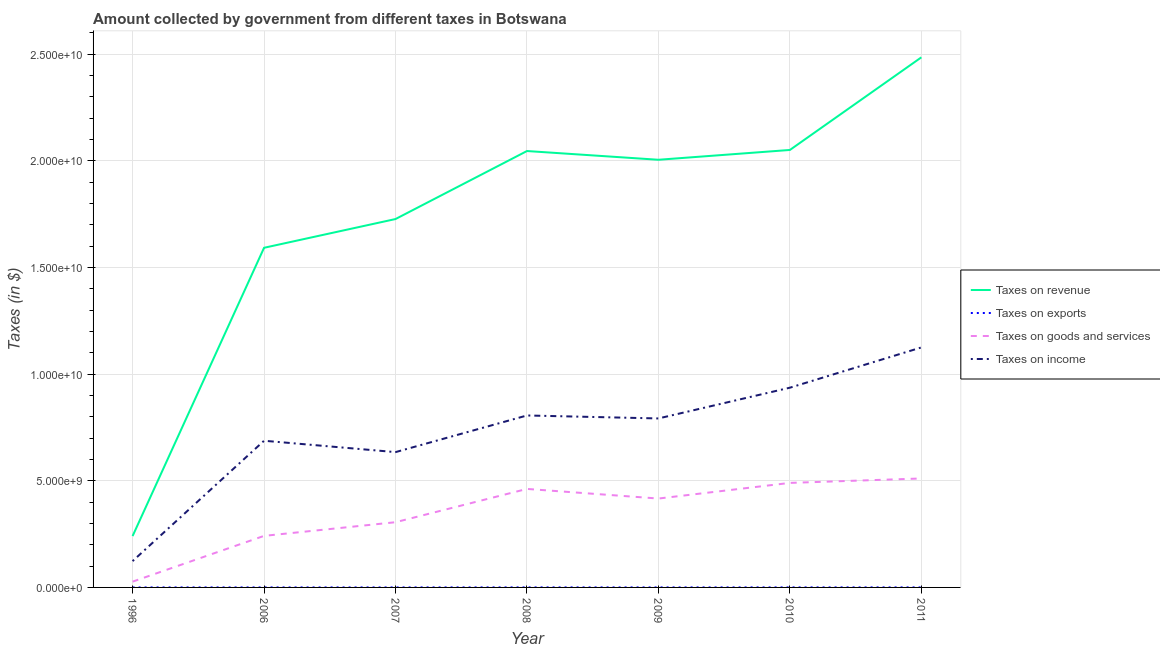What is the amount collected as tax on goods in 2009?
Your response must be concise. 4.17e+09. Across all years, what is the maximum amount collected as tax on exports?
Ensure brevity in your answer.  1.69e+06. Across all years, what is the minimum amount collected as tax on revenue?
Make the answer very short. 2.41e+09. In which year was the amount collected as tax on income minimum?
Provide a short and direct response. 1996. What is the total amount collected as tax on income in the graph?
Ensure brevity in your answer.  5.10e+1. What is the difference between the amount collected as tax on exports in 1996 and that in 2010?
Make the answer very short. -1.39e+06. What is the difference between the amount collected as tax on income in 2006 and the amount collected as tax on exports in 2008?
Keep it short and to the point. 6.87e+09. What is the average amount collected as tax on goods per year?
Keep it short and to the point. 3.50e+09. In the year 2011, what is the difference between the amount collected as tax on goods and amount collected as tax on revenue?
Offer a terse response. -1.97e+1. In how many years, is the amount collected as tax on goods greater than 11000000000 $?
Offer a terse response. 0. What is the ratio of the amount collected as tax on income in 2009 to that in 2010?
Offer a terse response. 0.85. Is the amount collected as tax on goods in 2009 less than that in 2010?
Keep it short and to the point. Yes. What is the difference between the highest and the second highest amount collected as tax on goods?
Make the answer very short. 2.08e+08. What is the difference between the highest and the lowest amount collected as tax on goods?
Your response must be concise. 4.84e+09. In how many years, is the amount collected as tax on goods greater than the average amount collected as tax on goods taken over all years?
Provide a succinct answer. 4. Is the sum of the amount collected as tax on exports in 2009 and 2011 greater than the maximum amount collected as tax on revenue across all years?
Your answer should be very brief. No. Does the amount collected as tax on goods monotonically increase over the years?
Provide a succinct answer. No. Is the amount collected as tax on goods strictly greater than the amount collected as tax on revenue over the years?
Keep it short and to the point. No. Is the amount collected as tax on exports strictly less than the amount collected as tax on income over the years?
Provide a short and direct response. Yes. How many lines are there?
Give a very brief answer. 4. How many years are there in the graph?
Keep it short and to the point. 7. Does the graph contain any zero values?
Your answer should be very brief. No. Does the graph contain grids?
Make the answer very short. Yes. How many legend labels are there?
Your answer should be compact. 4. What is the title of the graph?
Provide a short and direct response. Amount collected by government from different taxes in Botswana. Does "Taxes on income" appear as one of the legend labels in the graph?
Ensure brevity in your answer.  Yes. What is the label or title of the X-axis?
Ensure brevity in your answer.  Year. What is the label or title of the Y-axis?
Ensure brevity in your answer.  Taxes (in $). What is the Taxes (in $) in Taxes on revenue in 1996?
Your response must be concise. 2.41e+09. What is the Taxes (in $) in Taxes on exports in 1996?
Keep it short and to the point. 3.00e+05. What is the Taxes (in $) in Taxes on goods and services in 1996?
Offer a very short reply. 2.71e+08. What is the Taxes (in $) of Taxes on income in 1996?
Keep it short and to the point. 1.23e+09. What is the Taxes (in $) in Taxes on revenue in 2006?
Keep it short and to the point. 1.59e+1. What is the Taxes (in $) in Taxes on exports in 2006?
Your response must be concise. 3.60e+05. What is the Taxes (in $) of Taxes on goods and services in 2006?
Provide a short and direct response. 2.42e+09. What is the Taxes (in $) in Taxes on income in 2006?
Offer a terse response. 6.88e+09. What is the Taxes (in $) of Taxes on revenue in 2007?
Your answer should be compact. 1.73e+1. What is the Taxes (in $) in Taxes on goods and services in 2007?
Provide a short and direct response. 3.06e+09. What is the Taxes (in $) in Taxes on income in 2007?
Provide a short and direct response. 6.34e+09. What is the Taxes (in $) of Taxes on revenue in 2008?
Your answer should be compact. 2.05e+1. What is the Taxes (in $) in Taxes on exports in 2008?
Give a very brief answer. 1.65e+06. What is the Taxes (in $) of Taxes on goods and services in 2008?
Offer a terse response. 4.62e+09. What is the Taxes (in $) of Taxes on income in 2008?
Keep it short and to the point. 8.06e+09. What is the Taxes (in $) in Taxes on revenue in 2009?
Make the answer very short. 2.00e+1. What is the Taxes (in $) of Taxes on exports in 2009?
Make the answer very short. 7.10e+05. What is the Taxes (in $) of Taxes on goods and services in 2009?
Offer a very short reply. 4.17e+09. What is the Taxes (in $) in Taxes on income in 2009?
Your answer should be very brief. 7.92e+09. What is the Taxes (in $) of Taxes on revenue in 2010?
Your response must be concise. 2.05e+1. What is the Taxes (in $) in Taxes on exports in 2010?
Make the answer very short. 1.69e+06. What is the Taxes (in $) of Taxes on goods and services in 2010?
Your response must be concise. 4.90e+09. What is the Taxes (in $) in Taxes on income in 2010?
Your response must be concise. 9.36e+09. What is the Taxes (in $) in Taxes on revenue in 2011?
Your response must be concise. 2.48e+1. What is the Taxes (in $) in Taxes on exports in 2011?
Your answer should be compact. 1.36e+06. What is the Taxes (in $) in Taxes on goods and services in 2011?
Ensure brevity in your answer.  5.11e+09. What is the Taxes (in $) of Taxes on income in 2011?
Your response must be concise. 1.12e+1. Across all years, what is the maximum Taxes (in $) of Taxes on revenue?
Your answer should be very brief. 2.48e+1. Across all years, what is the maximum Taxes (in $) in Taxes on exports?
Your answer should be compact. 1.69e+06. Across all years, what is the maximum Taxes (in $) of Taxes on goods and services?
Make the answer very short. 5.11e+09. Across all years, what is the maximum Taxes (in $) of Taxes on income?
Ensure brevity in your answer.  1.12e+1. Across all years, what is the minimum Taxes (in $) in Taxes on revenue?
Offer a terse response. 2.41e+09. Across all years, what is the minimum Taxes (in $) of Taxes on exports?
Provide a short and direct response. 3.00e+05. Across all years, what is the minimum Taxes (in $) of Taxes on goods and services?
Provide a short and direct response. 2.71e+08. Across all years, what is the minimum Taxes (in $) in Taxes on income?
Your response must be concise. 1.23e+09. What is the total Taxes (in $) in Taxes on revenue in the graph?
Ensure brevity in your answer.  1.21e+11. What is the total Taxes (in $) of Taxes on exports in the graph?
Your answer should be very brief. 6.51e+06. What is the total Taxes (in $) in Taxes on goods and services in the graph?
Keep it short and to the point. 2.45e+1. What is the total Taxes (in $) in Taxes on income in the graph?
Ensure brevity in your answer.  5.10e+1. What is the difference between the Taxes (in $) in Taxes on revenue in 1996 and that in 2006?
Give a very brief answer. -1.35e+1. What is the difference between the Taxes (in $) in Taxes on exports in 1996 and that in 2006?
Keep it short and to the point. -6.00e+04. What is the difference between the Taxes (in $) in Taxes on goods and services in 1996 and that in 2006?
Ensure brevity in your answer.  -2.14e+09. What is the difference between the Taxes (in $) in Taxes on income in 1996 and that in 2006?
Offer a very short reply. -5.64e+09. What is the difference between the Taxes (in $) in Taxes on revenue in 1996 and that in 2007?
Make the answer very short. -1.49e+1. What is the difference between the Taxes (in $) of Taxes on goods and services in 1996 and that in 2007?
Ensure brevity in your answer.  -2.79e+09. What is the difference between the Taxes (in $) in Taxes on income in 1996 and that in 2007?
Give a very brief answer. -5.11e+09. What is the difference between the Taxes (in $) of Taxes on revenue in 1996 and that in 2008?
Provide a short and direct response. -1.80e+1. What is the difference between the Taxes (in $) of Taxes on exports in 1996 and that in 2008?
Keep it short and to the point. -1.35e+06. What is the difference between the Taxes (in $) in Taxes on goods and services in 1996 and that in 2008?
Keep it short and to the point. -4.35e+09. What is the difference between the Taxes (in $) of Taxes on income in 1996 and that in 2008?
Your answer should be compact. -6.83e+09. What is the difference between the Taxes (in $) in Taxes on revenue in 1996 and that in 2009?
Make the answer very short. -1.76e+1. What is the difference between the Taxes (in $) of Taxes on exports in 1996 and that in 2009?
Your answer should be very brief. -4.10e+05. What is the difference between the Taxes (in $) in Taxes on goods and services in 1996 and that in 2009?
Your answer should be compact. -3.89e+09. What is the difference between the Taxes (in $) of Taxes on income in 1996 and that in 2009?
Your response must be concise. -6.69e+09. What is the difference between the Taxes (in $) in Taxes on revenue in 1996 and that in 2010?
Your response must be concise. -1.81e+1. What is the difference between the Taxes (in $) of Taxes on exports in 1996 and that in 2010?
Give a very brief answer. -1.39e+06. What is the difference between the Taxes (in $) of Taxes on goods and services in 1996 and that in 2010?
Your answer should be compact. -4.63e+09. What is the difference between the Taxes (in $) of Taxes on income in 1996 and that in 2010?
Keep it short and to the point. -8.13e+09. What is the difference between the Taxes (in $) in Taxes on revenue in 1996 and that in 2011?
Provide a short and direct response. -2.24e+1. What is the difference between the Taxes (in $) of Taxes on exports in 1996 and that in 2011?
Provide a succinct answer. -1.06e+06. What is the difference between the Taxes (in $) of Taxes on goods and services in 1996 and that in 2011?
Provide a short and direct response. -4.84e+09. What is the difference between the Taxes (in $) in Taxes on income in 1996 and that in 2011?
Provide a succinct answer. -1.00e+1. What is the difference between the Taxes (in $) in Taxes on revenue in 2006 and that in 2007?
Your answer should be very brief. -1.35e+09. What is the difference between the Taxes (in $) of Taxes on exports in 2006 and that in 2007?
Offer a terse response. -8.00e+04. What is the difference between the Taxes (in $) of Taxes on goods and services in 2006 and that in 2007?
Offer a very short reply. -6.41e+08. What is the difference between the Taxes (in $) in Taxes on income in 2006 and that in 2007?
Offer a very short reply. 5.33e+08. What is the difference between the Taxes (in $) in Taxes on revenue in 2006 and that in 2008?
Provide a succinct answer. -4.54e+09. What is the difference between the Taxes (in $) of Taxes on exports in 2006 and that in 2008?
Make the answer very short. -1.29e+06. What is the difference between the Taxes (in $) in Taxes on goods and services in 2006 and that in 2008?
Provide a succinct answer. -2.20e+09. What is the difference between the Taxes (in $) of Taxes on income in 2006 and that in 2008?
Ensure brevity in your answer.  -1.18e+09. What is the difference between the Taxes (in $) of Taxes on revenue in 2006 and that in 2009?
Provide a short and direct response. -4.13e+09. What is the difference between the Taxes (in $) in Taxes on exports in 2006 and that in 2009?
Give a very brief answer. -3.50e+05. What is the difference between the Taxes (in $) in Taxes on goods and services in 2006 and that in 2009?
Offer a terse response. -1.75e+09. What is the difference between the Taxes (in $) in Taxes on income in 2006 and that in 2009?
Your response must be concise. -1.05e+09. What is the difference between the Taxes (in $) in Taxes on revenue in 2006 and that in 2010?
Provide a succinct answer. -4.59e+09. What is the difference between the Taxes (in $) of Taxes on exports in 2006 and that in 2010?
Offer a terse response. -1.33e+06. What is the difference between the Taxes (in $) of Taxes on goods and services in 2006 and that in 2010?
Make the answer very short. -2.48e+09. What is the difference between the Taxes (in $) of Taxes on income in 2006 and that in 2010?
Make the answer very short. -2.49e+09. What is the difference between the Taxes (in $) in Taxes on revenue in 2006 and that in 2011?
Your answer should be very brief. -8.93e+09. What is the difference between the Taxes (in $) of Taxes on goods and services in 2006 and that in 2011?
Offer a very short reply. -2.69e+09. What is the difference between the Taxes (in $) in Taxes on income in 2006 and that in 2011?
Offer a terse response. -4.37e+09. What is the difference between the Taxes (in $) of Taxes on revenue in 2007 and that in 2008?
Keep it short and to the point. -3.19e+09. What is the difference between the Taxes (in $) of Taxes on exports in 2007 and that in 2008?
Offer a terse response. -1.21e+06. What is the difference between the Taxes (in $) in Taxes on goods and services in 2007 and that in 2008?
Give a very brief answer. -1.56e+09. What is the difference between the Taxes (in $) of Taxes on income in 2007 and that in 2008?
Your answer should be very brief. -1.72e+09. What is the difference between the Taxes (in $) in Taxes on revenue in 2007 and that in 2009?
Offer a very short reply. -2.78e+09. What is the difference between the Taxes (in $) in Taxes on goods and services in 2007 and that in 2009?
Ensure brevity in your answer.  -1.11e+09. What is the difference between the Taxes (in $) of Taxes on income in 2007 and that in 2009?
Make the answer very short. -1.58e+09. What is the difference between the Taxes (in $) of Taxes on revenue in 2007 and that in 2010?
Offer a terse response. -3.24e+09. What is the difference between the Taxes (in $) in Taxes on exports in 2007 and that in 2010?
Provide a short and direct response. -1.25e+06. What is the difference between the Taxes (in $) of Taxes on goods and services in 2007 and that in 2010?
Your answer should be very brief. -1.84e+09. What is the difference between the Taxes (in $) of Taxes on income in 2007 and that in 2010?
Provide a short and direct response. -3.02e+09. What is the difference between the Taxes (in $) in Taxes on revenue in 2007 and that in 2011?
Make the answer very short. -7.58e+09. What is the difference between the Taxes (in $) in Taxes on exports in 2007 and that in 2011?
Ensure brevity in your answer.  -9.20e+05. What is the difference between the Taxes (in $) of Taxes on goods and services in 2007 and that in 2011?
Offer a terse response. -2.05e+09. What is the difference between the Taxes (in $) of Taxes on income in 2007 and that in 2011?
Ensure brevity in your answer.  -4.91e+09. What is the difference between the Taxes (in $) in Taxes on revenue in 2008 and that in 2009?
Provide a succinct answer. 4.09e+08. What is the difference between the Taxes (in $) of Taxes on exports in 2008 and that in 2009?
Keep it short and to the point. 9.40e+05. What is the difference between the Taxes (in $) in Taxes on goods and services in 2008 and that in 2009?
Your answer should be very brief. 4.51e+08. What is the difference between the Taxes (in $) of Taxes on income in 2008 and that in 2009?
Ensure brevity in your answer.  1.40e+08. What is the difference between the Taxes (in $) of Taxes on revenue in 2008 and that in 2010?
Provide a short and direct response. -5.03e+07. What is the difference between the Taxes (in $) of Taxes on exports in 2008 and that in 2010?
Give a very brief answer. -4.00e+04. What is the difference between the Taxes (in $) of Taxes on goods and services in 2008 and that in 2010?
Give a very brief answer. -2.82e+08. What is the difference between the Taxes (in $) in Taxes on income in 2008 and that in 2010?
Make the answer very short. -1.30e+09. What is the difference between the Taxes (in $) of Taxes on revenue in 2008 and that in 2011?
Your response must be concise. -4.39e+09. What is the difference between the Taxes (in $) in Taxes on exports in 2008 and that in 2011?
Make the answer very short. 2.90e+05. What is the difference between the Taxes (in $) in Taxes on goods and services in 2008 and that in 2011?
Keep it short and to the point. -4.90e+08. What is the difference between the Taxes (in $) of Taxes on income in 2008 and that in 2011?
Provide a succinct answer. -3.19e+09. What is the difference between the Taxes (in $) in Taxes on revenue in 2009 and that in 2010?
Provide a short and direct response. -4.60e+08. What is the difference between the Taxes (in $) in Taxes on exports in 2009 and that in 2010?
Your answer should be very brief. -9.80e+05. What is the difference between the Taxes (in $) of Taxes on goods and services in 2009 and that in 2010?
Keep it short and to the point. -7.34e+08. What is the difference between the Taxes (in $) in Taxes on income in 2009 and that in 2010?
Provide a succinct answer. -1.44e+09. What is the difference between the Taxes (in $) in Taxes on revenue in 2009 and that in 2011?
Keep it short and to the point. -4.80e+09. What is the difference between the Taxes (in $) in Taxes on exports in 2009 and that in 2011?
Give a very brief answer. -6.50e+05. What is the difference between the Taxes (in $) of Taxes on goods and services in 2009 and that in 2011?
Offer a terse response. -9.41e+08. What is the difference between the Taxes (in $) in Taxes on income in 2009 and that in 2011?
Provide a succinct answer. -3.33e+09. What is the difference between the Taxes (in $) in Taxes on revenue in 2010 and that in 2011?
Your answer should be compact. -4.34e+09. What is the difference between the Taxes (in $) of Taxes on exports in 2010 and that in 2011?
Ensure brevity in your answer.  3.30e+05. What is the difference between the Taxes (in $) of Taxes on goods and services in 2010 and that in 2011?
Give a very brief answer. -2.08e+08. What is the difference between the Taxes (in $) of Taxes on income in 2010 and that in 2011?
Provide a succinct answer. -1.89e+09. What is the difference between the Taxes (in $) in Taxes on revenue in 1996 and the Taxes (in $) in Taxes on exports in 2006?
Offer a very short reply. 2.41e+09. What is the difference between the Taxes (in $) in Taxes on revenue in 1996 and the Taxes (in $) in Taxes on goods and services in 2006?
Make the answer very short. -8.88e+06. What is the difference between the Taxes (in $) of Taxes on revenue in 1996 and the Taxes (in $) of Taxes on income in 2006?
Make the answer very short. -4.47e+09. What is the difference between the Taxes (in $) of Taxes on exports in 1996 and the Taxes (in $) of Taxes on goods and services in 2006?
Keep it short and to the point. -2.42e+09. What is the difference between the Taxes (in $) in Taxes on exports in 1996 and the Taxes (in $) in Taxes on income in 2006?
Your response must be concise. -6.87e+09. What is the difference between the Taxes (in $) in Taxes on goods and services in 1996 and the Taxes (in $) in Taxes on income in 2006?
Your response must be concise. -6.60e+09. What is the difference between the Taxes (in $) of Taxes on revenue in 1996 and the Taxes (in $) of Taxes on exports in 2007?
Keep it short and to the point. 2.41e+09. What is the difference between the Taxes (in $) in Taxes on revenue in 1996 and the Taxes (in $) in Taxes on goods and services in 2007?
Provide a short and direct response. -6.50e+08. What is the difference between the Taxes (in $) of Taxes on revenue in 1996 and the Taxes (in $) of Taxes on income in 2007?
Offer a terse response. -3.94e+09. What is the difference between the Taxes (in $) of Taxes on exports in 1996 and the Taxes (in $) of Taxes on goods and services in 2007?
Give a very brief answer. -3.06e+09. What is the difference between the Taxes (in $) in Taxes on exports in 1996 and the Taxes (in $) in Taxes on income in 2007?
Offer a very short reply. -6.34e+09. What is the difference between the Taxes (in $) in Taxes on goods and services in 1996 and the Taxes (in $) in Taxes on income in 2007?
Make the answer very short. -6.07e+09. What is the difference between the Taxes (in $) in Taxes on revenue in 1996 and the Taxes (in $) in Taxes on exports in 2008?
Make the answer very short. 2.41e+09. What is the difference between the Taxes (in $) in Taxes on revenue in 1996 and the Taxes (in $) in Taxes on goods and services in 2008?
Your response must be concise. -2.21e+09. What is the difference between the Taxes (in $) in Taxes on revenue in 1996 and the Taxes (in $) in Taxes on income in 2008?
Make the answer very short. -5.65e+09. What is the difference between the Taxes (in $) in Taxes on exports in 1996 and the Taxes (in $) in Taxes on goods and services in 2008?
Offer a very short reply. -4.62e+09. What is the difference between the Taxes (in $) in Taxes on exports in 1996 and the Taxes (in $) in Taxes on income in 2008?
Offer a terse response. -8.06e+09. What is the difference between the Taxes (in $) in Taxes on goods and services in 1996 and the Taxes (in $) in Taxes on income in 2008?
Your response must be concise. -7.79e+09. What is the difference between the Taxes (in $) in Taxes on revenue in 1996 and the Taxes (in $) in Taxes on exports in 2009?
Provide a short and direct response. 2.41e+09. What is the difference between the Taxes (in $) in Taxes on revenue in 1996 and the Taxes (in $) in Taxes on goods and services in 2009?
Your response must be concise. -1.76e+09. What is the difference between the Taxes (in $) of Taxes on revenue in 1996 and the Taxes (in $) of Taxes on income in 2009?
Offer a terse response. -5.51e+09. What is the difference between the Taxes (in $) in Taxes on exports in 1996 and the Taxes (in $) in Taxes on goods and services in 2009?
Ensure brevity in your answer.  -4.17e+09. What is the difference between the Taxes (in $) of Taxes on exports in 1996 and the Taxes (in $) of Taxes on income in 2009?
Provide a short and direct response. -7.92e+09. What is the difference between the Taxes (in $) in Taxes on goods and services in 1996 and the Taxes (in $) in Taxes on income in 2009?
Offer a very short reply. -7.65e+09. What is the difference between the Taxes (in $) in Taxes on revenue in 1996 and the Taxes (in $) in Taxes on exports in 2010?
Your answer should be very brief. 2.41e+09. What is the difference between the Taxes (in $) in Taxes on revenue in 1996 and the Taxes (in $) in Taxes on goods and services in 2010?
Your answer should be very brief. -2.49e+09. What is the difference between the Taxes (in $) in Taxes on revenue in 1996 and the Taxes (in $) in Taxes on income in 2010?
Provide a succinct answer. -6.96e+09. What is the difference between the Taxes (in $) of Taxes on exports in 1996 and the Taxes (in $) of Taxes on goods and services in 2010?
Offer a terse response. -4.90e+09. What is the difference between the Taxes (in $) of Taxes on exports in 1996 and the Taxes (in $) of Taxes on income in 2010?
Offer a terse response. -9.36e+09. What is the difference between the Taxes (in $) of Taxes on goods and services in 1996 and the Taxes (in $) of Taxes on income in 2010?
Offer a very short reply. -9.09e+09. What is the difference between the Taxes (in $) of Taxes on revenue in 1996 and the Taxes (in $) of Taxes on exports in 2011?
Make the answer very short. 2.41e+09. What is the difference between the Taxes (in $) in Taxes on revenue in 1996 and the Taxes (in $) in Taxes on goods and services in 2011?
Ensure brevity in your answer.  -2.70e+09. What is the difference between the Taxes (in $) in Taxes on revenue in 1996 and the Taxes (in $) in Taxes on income in 2011?
Make the answer very short. -8.84e+09. What is the difference between the Taxes (in $) in Taxes on exports in 1996 and the Taxes (in $) in Taxes on goods and services in 2011?
Offer a very short reply. -5.11e+09. What is the difference between the Taxes (in $) of Taxes on exports in 1996 and the Taxes (in $) of Taxes on income in 2011?
Your answer should be very brief. -1.12e+1. What is the difference between the Taxes (in $) in Taxes on goods and services in 1996 and the Taxes (in $) in Taxes on income in 2011?
Provide a short and direct response. -1.10e+1. What is the difference between the Taxes (in $) in Taxes on revenue in 2006 and the Taxes (in $) in Taxes on exports in 2007?
Ensure brevity in your answer.  1.59e+1. What is the difference between the Taxes (in $) of Taxes on revenue in 2006 and the Taxes (in $) of Taxes on goods and services in 2007?
Provide a short and direct response. 1.29e+1. What is the difference between the Taxes (in $) in Taxes on revenue in 2006 and the Taxes (in $) in Taxes on income in 2007?
Offer a very short reply. 9.58e+09. What is the difference between the Taxes (in $) in Taxes on exports in 2006 and the Taxes (in $) in Taxes on goods and services in 2007?
Make the answer very short. -3.06e+09. What is the difference between the Taxes (in $) in Taxes on exports in 2006 and the Taxes (in $) in Taxes on income in 2007?
Provide a short and direct response. -6.34e+09. What is the difference between the Taxes (in $) of Taxes on goods and services in 2006 and the Taxes (in $) of Taxes on income in 2007?
Offer a very short reply. -3.93e+09. What is the difference between the Taxes (in $) in Taxes on revenue in 2006 and the Taxes (in $) in Taxes on exports in 2008?
Offer a very short reply. 1.59e+1. What is the difference between the Taxes (in $) in Taxes on revenue in 2006 and the Taxes (in $) in Taxes on goods and services in 2008?
Ensure brevity in your answer.  1.13e+1. What is the difference between the Taxes (in $) in Taxes on revenue in 2006 and the Taxes (in $) in Taxes on income in 2008?
Your response must be concise. 7.86e+09. What is the difference between the Taxes (in $) in Taxes on exports in 2006 and the Taxes (in $) in Taxes on goods and services in 2008?
Offer a very short reply. -4.62e+09. What is the difference between the Taxes (in $) in Taxes on exports in 2006 and the Taxes (in $) in Taxes on income in 2008?
Your answer should be compact. -8.06e+09. What is the difference between the Taxes (in $) of Taxes on goods and services in 2006 and the Taxes (in $) of Taxes on income in 2008?
Your response must be concise. -5.64e+09. What is the difference between the Taxes (in $) of Taxes on revenue in 2006 and the Taxes (in $) of Taxes on exports in 2009?
Ensure brevity in your answer.  1.59e+1. What is the difference between the Taxes (in $) in Taxes on revenue in 2006 and the Taxes (in $) in Taxes on goods and services in 2009?
Provide a short and direct response. 1.18e+1. What is the difference between the Taxes (in $) of Taxes on revenue in 2006 and the Taxes (in $) of Taxes on income in 2009?
Your answer should be compact. 8.00e+09. What is the difference between the Taxes (in $) of Taxes on exports in 2006 and the Taxes (in $) of Taxes on goods and services in 2009?
Ensure brevity in your answer.  -4.17e+09. What is the difference between the Taxes (in $) in Taxes on exports in 2006 and the Taxes (in $) in Taxes on income in 2009?
Provide a short and direct response. -7.92e+09. What is the difference between the Taxes (in $) of Taxes on goods and services in 2006 and the Taxes (in $) of Taxes on income in 2009?
Provide a short and direct response. -5.50e+09. What is the difference between the Taxes (in $) of Taxes on revenue in 2006 and the Taxes (in $) of Taxes on exports in 2010?
Offer a terse response. 1.59e+1. What is the difference between the Taxes (in $) in Taxes on revenue in 2006 and the Taxes (in $) in Taxes on goods and services in 2010?
Give a very brief answer. 1.10e+1. What is the difference between the Taxes (in $) in Taxes on revenue in 2006 and the Taxes (in $) in Taxes on income in 2010?
Your response must be concise. 6.56e+09. What is the difference between the Taxes (in $) in Taxes on exports in 2006 and the Taxes (in $) in Taxes on goods and services in 2010?
Keep it short and to the point. -4.90e+09. What is the difference between the Taxes (in $) in Taxes on exports in 2006 and the Taxes (in $) in Taxes on income in 2010?
Give a very brief answer. -9.36e+09. What is the difference between the Taxes (in $) of Taxes on goods and services in 2006 and the Taxes (in $) of Taxes on income in 2010?
Provide a succinct answer. -6.95e+09. What is the difference between the Taxes (in $) in Taxes on revenue in 2006 and the Taxes (in $) in Taxes on exports in 2011?
Provide a succinct answer. 1.59e+1. What is the difference between the Taxes (in $) in Taxes on revenue in 2006 and the Taxes (in $) in Taxes on goods and services in 2011?
Give a very brief answer. 1.08e+1. What is the difference between the Taxes (in $) in Taxes on revenue in 2006 and the Taxes (in $) in Taxes on income in 2011?
Your response must be concise. 4.67e+09. What is the difference between the Taxes (in $) of Taxes on exports in 2006 and the Taxes (in $) of Taxes on goods and services in 2011?
Give a very brief answer. -5.11e+09. What is the difference between the Taxes (in $) in Taxes on exports in 2006 and the Taxes (in $) in Taxes on income in 2011?
Make the answer very short. -1.12e+1. What is the difference between the Taxes (in $) of Taxes on goods and services in 2006 and the Taxes (in $) of Taxes on income in 2011?
Offer a very short reply. -8.83e+09. What is the difference between the Taxes (in $) in Taxes on revenue in 2007 and the Taxes (in $) in Taxes on exports in 2008?
Give a very brief answer. 1.73e+1. What is the difference between the Taxes (in $) in Taxes on revenue in 2007 and the Taxes (in $) in Taxes on goods and services in 2008?
Your answer should be compact. 1.26e+1. What is the difference between the Taxes (in $) of Taxes on revenue in 2007 and the Taxes (in $) of Taxes on income in 2008?
Your answer should be very brief. 9.21e+09. What is the difference between the Taxes (in $) of Taxes on exports in 2007 and the Taxes (in $) of Taxes on goods and services in 2008?
Offer a very short reply. -4.62e+09. What is the difference between the Taxes (in $) in Taxes on exports in 2007 and the Taxes (in $) in Taxes on income in 2008?
Provide a succinct answer. -8.06e+09. What is the difference between the Taxes (in $) of Taxes on goods and services in 2007 and the Taxes (in $) of Taxes on income in 2008?
Your response must be concise. -5.00e+09. What is the difference between the Taxes (in $) in Taxes on revenue in 2007 and the Taxes (in $) in Taxes on exports in 2009?
Make the answer very short. 1.73e+1. What is the difference between the Taxes (in $) in Taxes on revenue in 2007 and the Taxes (in $) in Taxes on goods and services in 2009?
Your response must be concise. 1.31e+1. What is the difference between the Taxes (in $) in Taxes on revenue in 2007 and the Taxes (in $) in Taxes on income in 2009?
Keep it short and to the point. 9.35e+09. What is the difference between the Taxes (in $) of Taxes on exports in 2007 and the Taxes (in $) of Taxes on goods and services in 2009?
Offer a terse response. -4.17e+09. What is the difference between the Taxes (in $) in Taxes on exports in 2007 and the Taxes (in $) in Taxes on income in 2009?
Give a very brief answer. -7.92e+09. What is the difference between the Taxes (in $) in Taxes on goods and services in 2007 and the Taxes (in $) in Taxes on income in 2009?
Offer a very short reply. -4.86e+09. What is the difference between the Taxes (in $) in Taxes on revenue in 2007 and the Taxes (in $) in Taxes on exports in 2010?
Give a very brief answer. 1.73e+1. What is the difference between the Taxes (in $) in Taxes on revenue in 2007 and the Taxes (in $) in Taxes on goods and services in 2010?
Your answer should be very brief. 1.24e+1. What is the difference between the Taxes (in $) of Taxes on revenue in 2007 and the Taxes (in $) of Taxes on income in 2010?
Make the answer very short. 7.90e+09. What is the difference between the Taxes (in $) of Taxes on exports in 2007 and the Taxes (in $) of Taxes on goods and services in 2010?
Provide a short and direct response. -4.90e+09. What is the difference between the Taxes (in $) of Taxes on exports in 2007 and the Taxes (in $) of Taxes on income in 2010?
Your response must be concise. -9.36e+09. What is the difference between the Taxes (in $) in Taxes on goods and services in 2007 and the Taxes (in $) in Taxes on income in 2010?
Provide a succinct answer. -6.31e+09. What is the difference between the Taxes (in $) in Taxes on revenue in 2007 and the Taxes (in $) in Taxes on exports in 2011?
Ensure brevity in your answer.  1.73e+1. What is the difference between the Taxes (in $) of Taxes on revenue in 2007 and the Taxes (in $) of Taxes on goods and services in 2011?
Your answer should be very brief. 1.22e+1. What is the difference between the Taxes (in $) in Taxes on revenue in 2007 and the Taxes (in $) in Taxes on income in 2011?
Keep it short and to the point. 6.02e+09. What is the difference between the Taxes (in $) in Taxes on exports in 2007 and the Taxes (in $) in Taxes on goods and services in 2011?
Keep it short and to the point. -5.11e+09. What is the difference between the Taxes (in $) in Taxes on exports in 2007 and the Taxes (in $) in Taxes on income in 2011?
Keep it short and to the point. -1.12e+1. What is the difference between the Taxes (in $) of Taxes on goods and services in 2007 and the Taxes (in $) of Taxes on income in 2011?
Provide a succinct answer. -8.19e+09. What is the difference between the Taxes (in $) of Taxes on revenue in 2008 and the Taxes (in $) of Taxes on exports in 2009?
Your answer should be very brief. 2.05e+1. What is the difference between the Taxes (in $) in Taxes on revenue in 2008 and the Taxes (in $) in Taxes on goods and services in 2009?
Offer a terse response. 1.63e+1. What is the difference between the Taxes (in $) of Taxes on revenue in 2008 and the Taxes (in $) of Taxes on income in 2009?
Keep it short and to the point. 1.25e+1. What is the difference between the Taxes (in $) of Taxes on exports in 2008 and the Taxes (in $) of Taxes on goods and services in 2009?
Make the answer very short. -4.16e+09. What is the difference between the Taxes (in $) of Taxes on exports in 2008 and the Taxes (in $) of Taxes on income in 2009?
Provide a short and direct response. -7.92e+09. What is the difference between the Taxes (in $) of Taxes on goods and services in 2008 and the Taxes (in $) of Taxes on income in 2009?
Provide a short and direct response. -3.30e+09. What is the difference between the Taxes (in $) of Taxes on revenue in 2008 and the Taxes (in $) of Taxes on exports in 2010?
Your response must be concise. 2.05e+1. What is the difference between the Taxes (in $) of Taxes on revenue in 2008 and the Taxes (in $) of Taxes on goods and services in 2010?
Provide a short and direct response. 1.56e+1. What is the difference between the Taxes (in $) of Taxes on revenue in 2008 and the Taxes (in $) of Taxes on income in 2010?
Your answer should be compact. 1.11e+1. What is the difference between the Taxes (in $) in Taxes on exports in 2008 and the Taxes (in $) in Taxes on goods and services in 2010?
Offer a terse response. -4.90e+09. What is the difference between the Taxes (in $) of Taxes on exports in 2008 and the Taxes (in $) of Taxes on income in 2010?
Provide a succinct answer. -9.36e+09. What is the difference between the Taxes (in $) of Taxes on goods and services in 2008 and the Taxes (in $) of Taxes on income in 2010?
Give a very brief answer. -4.75e+09. What is the difference between the Taxes (in $) of Taxes on revenue in 2008 and the Taxes (in $) of Taxes on exports in 2011?
Make the answer very short. 2.05e+1. What is the difference between the Taxes (in $) in Taxes on revenue in 2008 and the Taxes (in $) in Taxes on goods and services in 2011?
Provide a succinct answer. 1.53e+1. What is the difference between the Taxes (in $) in Taxes on revenue in 2008 and the Taxes (in $) in Taxes on income in 2011?
Provide a short and direct response. 9.21e+09. What is the difference between the Taxes (in $) of Taxes on exports in 2008 and the Taxes (in $) of Taxes on goods and services in 2011?
Offer a very short reply. -5.11e+09. What is the difference between the Taxes (in $) of Taxes on exports in 2008 and the Taxes (in $) of Taxes on income in 2011?
Your answer should be very brief. -1.12e+1. What is the difference between the Taxes (in $) in Taxes on goods and services in 2008 and the Taxes (in $) in Taxes on income in 2011?
Offer a very short reply. -6.63e+09. What is the difference between the Taxes (in $) in Taxes on revenue in 2009 and the Taxes (in $) in Taxes on exports in 2010?
Give a very brief answer. 2.00e+1. What is the difference between the Taxes (in $) in Taxes on revenue in 2009 and the Taxes (in $) in Taxes on goods and services in 2010?
Your answer should be very brief. 1.51e+1. What is the difference between the Taxes (in $) in Taxes on revenue in 2009 and the Taxes (in $) in Taxes on income in 2010?
Your answer should be compact. 1.07e+1. What is the difference between the Taxes (in $) of Taxes on exports in 2009 and the Taxes (in $) of Taxes on goods and services in 2010?
Offer a terse response. -4.90e+09. What is the difference between the Taxes (in $) in Taxes on exports in 2009 and the Taxes (in $) in Taxes on income in 2010?
Give a very brief answer. -9.36e+09. What is the difference between the Taxes (in $) of Taxes on goods and services in 2009 and the Taxes (in $) of Taxes on income in 2010?
Provide a succinct answer. -5.20e+09. What is the difference between the Taxes (in $) in Taxes on revenue in 2009 and the Taxes (in $) in Taxes on exports in 2011?
Keep it short and to the point. 2.00e+1. What is the difference between the Taxes (in $) in Taxes on revenue in 2009 and the Taxes (in $) in Taxes on goods and services in 2011?
Your answer should be compact. 1.49e+1. What is the difference between the Taxes (in $) in Taxes on revenue in 2009 and the Taxes (in $) in Taxes on income in 2011?
Make the answer very short. 8.80e+09. What is the difference between the Taxes (in $) of Taxes on exports in 2009 and the Taxes (in $) of Taxes on goods and services in 2011?
Offer a very short reply. -5.11e+09. What is the difference between the Taxes (in $) of Taxes on exports in 2009 and the Taxes (in $) of Taxes on income in 2011?
Make the answer very short. -1.12e+1. What is the difference between the Taxes (in $) of Taxes on goods and services in 2009 and the Taxes (in $) of Taxes on income in 2011?
Make the answer very short. -7.08e+09. What is the difference between the Taxes (in $) of Taxes on revenue in 2010 and the Taxes (in $) of Taxes on exports in 2011?
Make the answer very short. 2.05e+1. What is the difference between the Taxes (in $) in Taxes on revenue in 2010 and the Taxes (in $) in Taxes on goods and services in 2011?
Make the answer very short. 1.54e+1. What is the difference between the Taxes (in $) in Taxes on revenue in 2010 and the Taxes (in $) in Taxes on income in 2011?
Your response must be concise. 9.26e+09. What is the difference between the Taxes (in $) of Taxes on exports in 2010 and the Taxes (in $) of Taxes on goods and services in 2011?
Offer a terse response. -5.11e+09. What is the difference between the Taxes (in $) of Taxes on exports in 2010 and the Taxes (in $) of Taxes on income in 2011?
Provide a succinct answer. -1.12e+1. What is the difference between the Taxes (in $) of Taxes on goods and services in 2010 and the Taxes (in $) of Taxes on income in 2011?
Give a very brief answer. -6.35e+09. What is the average Taxes (in $) in Taxes on revenue per year?
Keep it short and to the point. 1.73e+1. What is the average Taxes (in $) of Taxes on exports per year?
Ensure brevity in your answer.  9.30e+05. What is the average Taxes (in $) in Taxes on goods and services per year?
Provide a short and direct response. 3.50e+09. What is the average Taxes (in $) of Taxes on income per year?
Make the answer very short. 7.29e+09. In the year 1996, what is the difference between the Taxes (in $) of Taxes on revenue and Taxes (in $) of Taxes on exports?
Offer a terse response. 2.41e+09. In the year 1996, what is the difference between the Taxes (in $) of Taxes on revenue and Taxes (in $) of Taxes on goods and services?
Offer a very short reply. 2.14e+09. In the year 1996, what is the difference between the Taxes (in $) of Taxes on revenue and Taxes (in $) of Taxes on income?
Provide a succinct answer. 1.17e+09. In the year 1996, what is the difference between the Taxes (in $) of Taxes on exports and Taxes (in $) of Taxes on goods and services?
Give a very brief answer. -2.71e+08. In the year 1996, what is the difference between the Taxes (in $) of Taxes on exports and Taxes (in $) of Taxes on income?
Provide a succinct answer. -1.23e+09. In the year 1996, what is the difference between the Taxes (in $) in Taxes on goods and services and Taxes (in $) in Taxes on income?
Offer a very short reply. -9.63e+08. In the year 2006, what is the difference between the Taxes (in $) of Taxes on revenue and Taxes (in $) of Taxes on exports?
Provide a short and direct response. 1.59e+1. In the year 2006, what is the difference between the Taxes (in $) in Taxes on revenue and Taxes (in $) in Taxes on goods and services?
Your answer should be compact. 1.35e+1. In the year 2006, what is the difference between the Taxes (in $) of Taxes on revenue and Taxes (in $) of Taxes on income?
Your answer should be compact. 9.04e+09. In the year 2006, what is the difference between the Taxes (in $) in Taxes on exports and Taxes (in $) in Taxes on goods and services?
Make the answer very short. -2.42e+09. In the year 2006, what is the difference between the Taxes (in $) in Taxes on exports and Taxes (in $) in Taxes on income?
Provide a short and direct response. -6.87e+09. In the year 2006, what is the difference between the Taxes (in $) in Taxes on goods and services and Taxes (in $) in Taxes on income?
Offer a very short reply. -4.46e+09. In the year 2007, what is the difference between the Taxes (in $) in Taxes on revenue and Taxes (in $) in Taxes on exports?
Keep it short and to the point. 1.73e+1. In the year 2007, what is the difference between the Taxes (in $) in Taxes on revenue and Taxes (in $) in Taxes on goods and services?
Ensure brevity in your answer.  1.42e+1. In the year 2007, what is the difference between the Taxes (in $) in Taxes on revenue and Taxes (in $) in Taxes on income?
Your answer should be very brief. 1.09e+1. In the year 2007, what is the difference between the Taxes (in $) of Taxes on exports and Taxes (in $) of Taxes on goods and services?
Offer a very short reply. -3.06e+09. In the year 2007, what is the difference between the Taxes (in $) of Taxes on exports and Taxes (in $) of Taxes on income?
Provide a succinct answer. -6.34e+09. In the year 2007, what is the difference between the Taxes (in $) in Taxes on goods and services and Taxes (in $) in Taxes on income?
Your response must be concise. -3.29e+09. In the year 2008, what is the difference between the Taxes (in $) of Taxes on revenue and Taxes (in $) of Taxes on exports?
Provide a succinct answer. 2.05e+1. In the year 2008, what is the difference between the Taxes (in $) of Taxes on revenue and Taxes (in $) of Taxes on goods and services?
Give a very brief answer. 1.58e+1. In the year 2008, what is the difference between the Taxes (in $) of Taxes on revenue and Taxes (in $) of Taxes on income?
Your answer should be very brief. 1.24e+1. In the year 2008, what is the difference between the Taxes (in $) of Taxes on exports and Taxes (in $) of Taxes on goods and services?
Offer a terse response. -4.62e+09. In the year 2008, what is the difference between the Taxes (in $) in Taxes on exports and Taxes (in $) in Taxes on income?
Your answer should be compact. -8.06e+09. In the year 2008, what is the difference between the Taxes (in $) in Taxes on goods and services and Taxes (in $) in Taxes on income?
Offer a terse response. -3.44e+09. In the year 2009, what is the difference between the Taxes (in $) in Taxes on revenue and Taxes (in $) in Taxes on exports?
Provide a succinct answer. 2.00e+1. In the year 2009, what is the difference between the Taxes (in $) in Taxes on revenue and Taxes (in $) in Taxes on goods and services?
Your answer should be compact. 1.59e+1. In the year 2009, what is the difference between the Taxes (in $) of Taxes on revenue and Taxes (in $) of Taxes on income?
Ensure brevity in your answer.  1.21e+1. In the year 2009, what is the difference between the Taxes (in $) in Taxes on exports and Taxes (in $) in Taxes on goods and services?
Make the answer very short. -4.17e+09. In the year 2009, what is the difference between the Taxes (in $) of Taxes on exports and Taxes (in $) of Taxes on income?
Keep it short and to the point. -7.92e+09. In the year 2009, what is the difference between the Taxes (in $) of Taxes on goods and services and Taxes (in $) of Taxes on income?
Give a very brief answer. -3.75e+09. In the year 2010, what is the difference between the Taxes (in $) of Taxes on revenue and Taxes (in $) of Taxes on exports?
Provide a succinct answer. 2.05e+1. In the year 2010, what is the difference between the Taxes (in $) in Taxes on revenue and Taxes (in $) in Taxes on goods and services?
Your response must be concise. 1.56e+1. In the year 2010, what is the difference between the Taxes (in $) of Taxes on revenue and Taxes (in $) of Taxes on income?
Provide a short and direct response. 1.11e+1. In the year 2010, what is the difference between the Taxes (in $) in Taxes on exports and Taxes (in $) in Taxes on goods and services?
Offer a very short reply. -4.90e+09. In the year 2010, what is the difference between the Taxes (in $) of Taxes on exports and Taxes (in $) of Taxes on income?
Ensure brevity in your answer.  -9.36e+09. In the year 2010, what is the difference between the Taxes (in $) in Taxes on goods and services and Taxes (in $) in Taxes on income?
Offer a terse response. -4.46e+09. In the year 2011, what is the difference between the Taxes (in $) in Taxes on revenue and Taxes (in $) in Taxes on exports?
Your answer should be very brief. 2.48e+1. In the year 2011, what is the difference between the Taxes (in $) of Taxes on revenue and Taxes (in $) of Taxes on goods and services?
Make the answer very short. 1.97e+1. In the year 2011, what is the difference between the Taxes (in $) in Taxes on revenue and Taxes (in $) in Taxes on income?
Your answer should be compact. 1.36e+1. In the year 2011, what is the difference between the Taxes (in $) in Taxes on exports and Taxes (in $) in Taxes on goods and services?
Your answer should be very brief. -5.11e+09. In the year 2011, what is the difference between the Taxes (in $) in Taxes on exports and Taxes (in $) in Taxes on income?
Your answer should be very brief. -1.12e+1. In the year 2011, what is the difference between the Taxes (in $) in Taxes on goods and services and Taxes (in $) in Taxes on income?
Your response must be concise. -6.14e+09. What is the ratio of the Taxes (in $) of Taxes on revenue in 1996 to that in 2006?
Ensure brevity in your answer.  0.15. What is the ratio of the Taxes (in $) of Taxes on exports in 1996 to that in 2006?
Ensure brevity in your answer.  0.83. What is the ratio of the Taxes (in $) of Taxes on goods and services in 1996 to that in 2006?
Provide a short and direct response. 0.11. What is the ratio of the Taxes (in $) in Taxes on income in 1996 to that in 2006?
Your answer should be compact. 0.18. What is the ratio of the Taxes (in $) in Taxes on revenue in 1996 to that in 2007?
Your response must be concise. 0.14. What is the ratio of the Taxes (in $) of Taxes on exports in 1996 to that in 2007?
Give a very brief answer. 0.68. What is the ratio of the Taxes (in $) of Taxes on goods and services in 1996 to that in 2007?
Give a very brief answer. 0.09. What is the ratio of the Taxes (in $) of Taxes on income in 1996 to that in 2007?
Your answer should be very brief. 0.19. What is the ratio of the Taxes (in $) in Taxes on revenue in 1996 to that in 2008?
Keep it short and to the point. 0.12. What is the ratio of the Taxes (in $) of Taxes on exports in 1996 to that in 2008?
Your answer should be very brief. 0.18. What is the ratio of the Taxes (in $) in Taxes on goods and services in 1996 to that in 2008?
Provide a succinct answer. 0.06. What is the ratio of the Taxes (in $) of Taxes on income in 1996 to that in 2008?
Keep it short and to the point. 0.15. What is the ratio of the Taxes (in $) in Taxes on revenue in 1996 to that in 2009?
Make the answer very short. 0.12. What is the ratio of the Taxes (in $) of Taxes on exports in 1996 to that in 2009?
Keep it short and to the point. 0.42. What is the ratio of the Taxes (in $) of Taxes on goods and services in 1996 to that in 2009?
Provide a short and direct response. 0.07. What is the ratio of the Taxes (in $) in Taxes on income in 1996 to that in 2009?
Make the answer very short. 0.16. What is the ratio of the Taxes (in $) of Taxes on revenue in 1996 to that in 2010?
Provide a succinct answer. 0.12. What is the ratio of the Taxes (in $) of Taxes on exports in 1996 to that in 2010?
Give a very brief answer. 0.18. What is the ratio of the Taxes (in $) of Taxes on goods and services in 1996 to that in 2010?
Provide a short and direct response. 0.06. What is the ratio of the Taxes (in $) in Taxes on income in 1996 to that in 2010?
Offer a terse response. 0.13. What is the ratio of the Taxes (in $) of Taxes on revenue in 1996 to that in 2011?
Make the answer very short. 0.1. What is the ratio of the Taxes (in $) of Taxes on exports in 1996 to that in 2011?
Your answer should be very brief. 0.22. What is the ratio of the Taxes (in $) of Taxes on goods and services in 1996 to that in 2011?
Your answer should be compact. 0.05. What is the ratio of the Taxes (in $) of Taxes on income in 1996 to that in 2011?
Make the answer very short. 0.11. What is the ratio of the Taxes (in $) of Taxes on revenue in 2006 to that in 2007?
Ensure brevity in your answer.  0.92. What is the ratio of the Taxes (in $) in Taxes on exports in 2006 to that in 2007?
Offer a very short reply. 0.82. What is the ratio of the Taxes (in $) of Taxes on goods and services in 2006 to that in 2007?
Your answer should be very brief. 0.79. What is the ratio of the Taxes (in $) in Taxes on income in 2006 to that in 2007?
Your answer should be compact. 1.08. What is the ratio of the Taxes (in $) of Taxes on revenue in 2006 to that in 2008?
Offer a very short reply. 0.78. What is the ratio of the Taxes (in $) of Taxes on exports in 2006 to that in 2008?
Your response must be concise. 0.22. What is the ratio of the Taxes (in $) in Taxes on goods and services in 2006 to that in 2008?
Ensure brevity in your answer.  0.52. What is the ratio of the Taxes (in $) of Taxes on income in 2006 to that in 2008?
Keep it short and to the point. 0.85. What is the ratio of the Taxes (in $) in Taxes on revenue in 2006 to that in 2009?
Make the answer very short. 0.79. What is the ratio of the Taxes (in $) in Taxes on exports in 2006 to that in 2009?
Provide a short and direct response. 0.51. What is the ratio of the Taxes (in $) in Taxes on goods and services in 2006 to that in 2009?
Keep it short and to the point. 0.58. What is the ratio of the Taxes (in $) of Taxes on income in 2006 to that in 2009?
Your answer should be very brief. 0.87. What is the ratio of the Taxes (in $) of Taxes on revenue in 2006 to that in 2010?
Offer a terse response. 0.78. What is the ratio of the Taxes (in $) of Taxes on exports in 2006 to that in 2010?
Make the answer very short. 0.21. What is the ratio of the Taxes (in $) in Taxes on goods and services in 2006 to that in 2010?
Offer a terse response. 0.49. What is the ratio of the Taxes (in $) of Taxes on income in 2006 to that in 2010?
Your response must be concise. 0.73. What is the ratio of the Taxes (in $) of Taxes on revenue in 2006 to that in 2011?
Provide a short and direct response. 0.64. What is the ratio of the Taxes (in $) of Taxes on exports in 2006 to that in 2011?
Keep it short and to the point. 0.26. What is the ratio of the Taxes (in $) in Taxes on goods and services in 2006 to that in 2011?
Ensure brevity in your answer.  0.47. What is the ratio of the Taxes (in $) in Taxes on income in 2006 to that in 2011?
Your response must be concise. 0.61. What is the ratio of the Taxes (in $) of Taxes on revenue in 2007 to that in 2008?
Your response must be concise. 0.84. What is the ratio of the Taxes (in $) in Taxes on exports in 2007 to that in 2008?
Give a very brief answer. 0.27. What is the ratio of the Taxes (in $) of Taxes on goods and services in 2007 to that in 2008?
Make the answer very short. 0.66. What is the ratio of the Taxes (in $) of Taxes on income in 2007 to that in 2008?
Provide a succinct answer. 0.79. What is the ratio of the Taxes (in $) in Taxes on revenue in 2007 to that in 2009?
Provide a succinct answer. 0.86. What is the ratio of the Taxes (in $) in Taxes on exports in 2007 to that in 2009?
Ensure brevity in your answer.  0.62. What is the ratio of the Taxes (in $) of Taxes on goods and services in 2007 to that in 2009?
Offer a very short reply. 0.73. What is the ratio of the Taxes (in $) of Taxes on income in 2007 to that in 2009?
Give a very brief answer. 0.8. What is the ratio of the Taxes (in $) in Taxes on revenue in 2007 to that in 2010?
Your answer should be compact. 0.84. What is the ratio of the Taxes (in $) in Taxes on exports in 2007 to that in 2010?
Your answer should be compact. 0.26. What is the ratio of the Taxes (in $) in Taxes on goods and services in 2007 to that in 2010?
Offer a very short reply. 0.62. What is the ratio of the Taxes (in $) in Taxes on income in 2007 to that in 2010?
Offer a very short reply. 0.68. What is the ratio of the Taxes (in $) of Taxes on revenue in 2007 to that in 2011?
Make the answer very short. 0.69. What is the ratio of the Taxes (in $) of Taxes on exports in 2007 to that in 2011?
Make the answer very short. 0.32. What is the ratio of the Taxes (in $) in Taxes on goods and services in 2007 to that in 2011?
Keep it short and to the point. 0.6. What is the ratio of the Taxes (in $) of Taxes on income in 2007 to that in 2011?
Keep it short and to the point. 0.56. What is the ratio of the Taxes (in $) in Taxes on revenue in 2008 to that in 2009?
Your response must be concise. 1.02. What is the ratio of the Taxes (in $) in Taxes on exports in 2008 to that in 2009?
Your answer should be very brief. 2.32. What is the ratio of the Taxes (in $) of Taxes on goods and services in 2008 to that in 2009?
Your answer should be very brief. 1.11. What is the ratio of the Taxes (in $) of Taxes on income in 2008 to that in 2009?
Ensure brevity in your answer.  1.02. What is the ratio of the Taxes (in $) of Taxes on exports in 2008 to that in 2010?
Provide a short and direct response. 0.98. What is the ratio of the Taxes (in $) of Taxes on goods and services in 2008 to that in 2010?
Ensure brevity in your answer.  0.94. What is the ratio of the Taxes (in $) in Taxes on income in 2008 to that in 2010?
Your response must be concise. 0.86. What is the ratio of the Taxes (in $) in Taxes on revenue in 2008 to that in 2011?
Your response must be concise. 0.82. What is the ratio of the Taxes (in $) of Taxes on exports in 2008 to that in 2011?
Offer a terse response. 1.21. What is the ratio of the Taxes (in $) of Taxes on goods and services in 2008 to that in 2011?
Give a very brief answer. 0.9. What is the ratio of the Taxes (in $) of Taxes on income in 2008 to that in 2011?
Offer a terse response. 0.72. What is the ratio of the Taxes (in $) in Taxes on revenue in 2009 to that in 2010?
Keep it short and to the point. 0.98. What is the ratio of the Taxes (in $) of Taxes on exports in 2009 to that in 2010?
Give a very brief answer. 0.42. What is the ratio of the Taxes (in $) of Taxes on goods and services in 2009 to that in 2010?
Give a very brief answer. 0.85. What is the ratio of the Taxes (in $) of Taxes on income in 2009 to that in 2010?
Offer a very short reply. 0.85. What is the ratio of the Taxes (in $) of Taxes on revenue in 2009 to that in 2011?
Make the answer very short. 0.81. What is the ratio of the Taxes (in $) of Taxes on exports in 2009 to that in 2011?
Your answer should be compact. 0.52. What is the ratio of the Taxes (in $) in Taxes on goods and services in 2009 to that in 2011?
Keep it short and to the point. 0.82. What is the ratio of the Taxes (in $) of Taxes on income in 2009 to that in 2011?
Provide a short and direct response. 0.7. What is the ratio of the Taxes (in $) in Taxes on revenue in 2010 to that in 2011?
Offer a terse response. 0.83. What is the ratio of the Taxes (in $) of Taxes on exports in 2010 to that in 2011?
Keep it short and to the point. 1.24. What is the ratio of the Taxes (in $) of Taxes on goods and services in 2010 to that in 2011?
Your answer should be very brief. 0.96. What is the ratio of the Taxes (in $) in Taxes on income in 2010 to that in 2011?
Ensure brevity in your answer.  0.83. What is the difference between the highest and the second highest Taxes (in $) in Taxes on revenue?
Offer a terse response. 4.34e+09. What is the difference between the highest and the second highest Taxes (in $) in Taxes on exports?
Your response must be concise. 4.00e+04. What is the difference between the highest and the second highest Taxes (in $) of Taxes on goods and services?
Your answer should be compact. 2.08e+08. What is the difference between the highest and the second highest Taxes (in $) of Taxes on income?
Your response must be concise. 1.89e+09. What is the difference between the highest and the lowest Taxes (in $) in Taxes on revenue?
Provide a succinct answer. 2.24e+1. What is the difference between the highest and the lowest Taxes (in $) in Taxes on exports?
Keep it short and to the point. 1.39e+06. What is the difference between the highest and the lowest Taxes (in $) of Taxes on goods and services?
Offer a very short reply. 4.84e+09. What is the difference between the highest and the lowest Taxes (in $) in Taxes on income?
Give a very brief answer. 1.00e+1. 